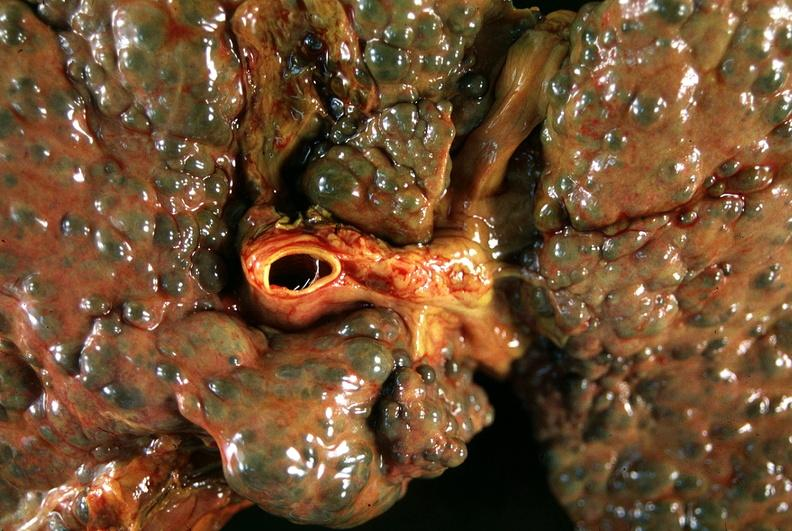s mesentery present?
Answer the question using a single word or phrase. No 